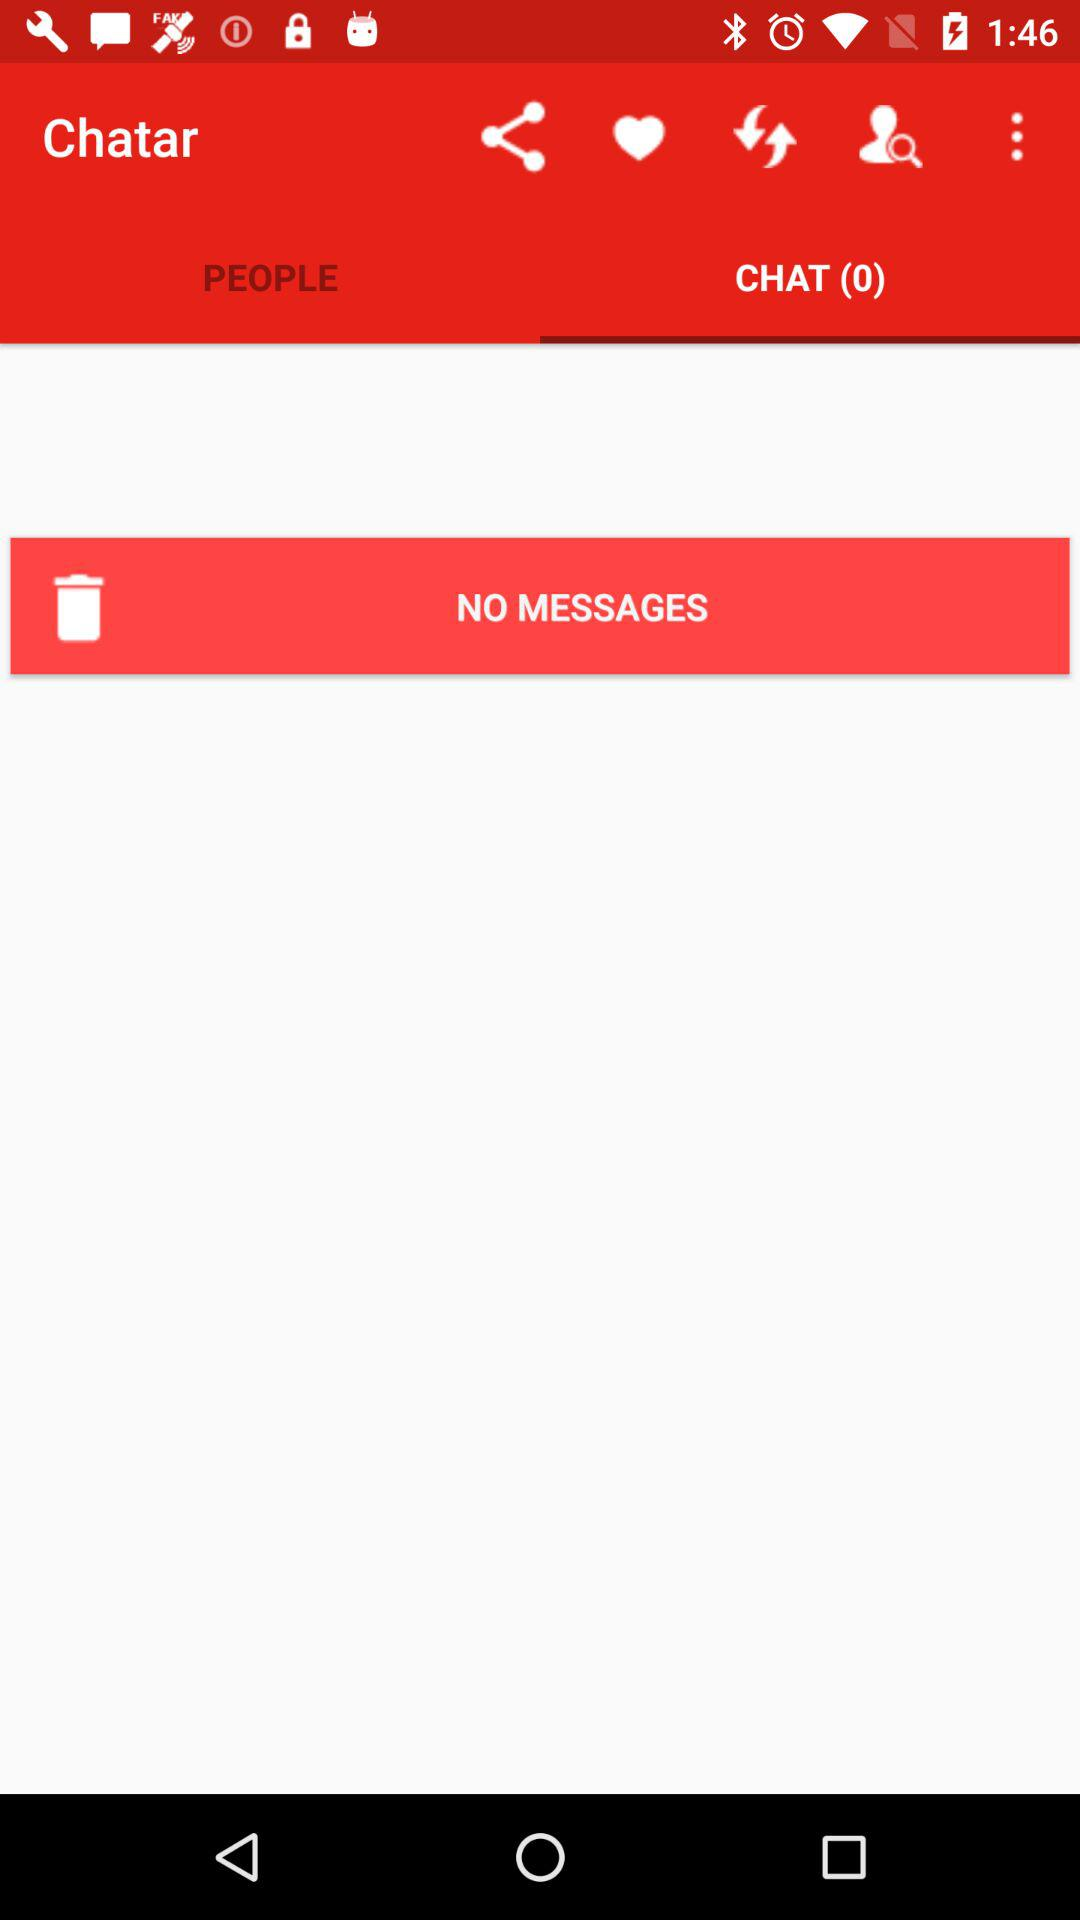How many chats are available? There are 0 chats available. 